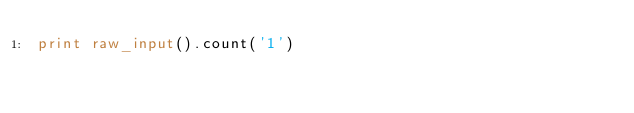<code> <loc_0><loc_0><loc_500><loc_500><_Python_>print raw_input().count('1')</code> 